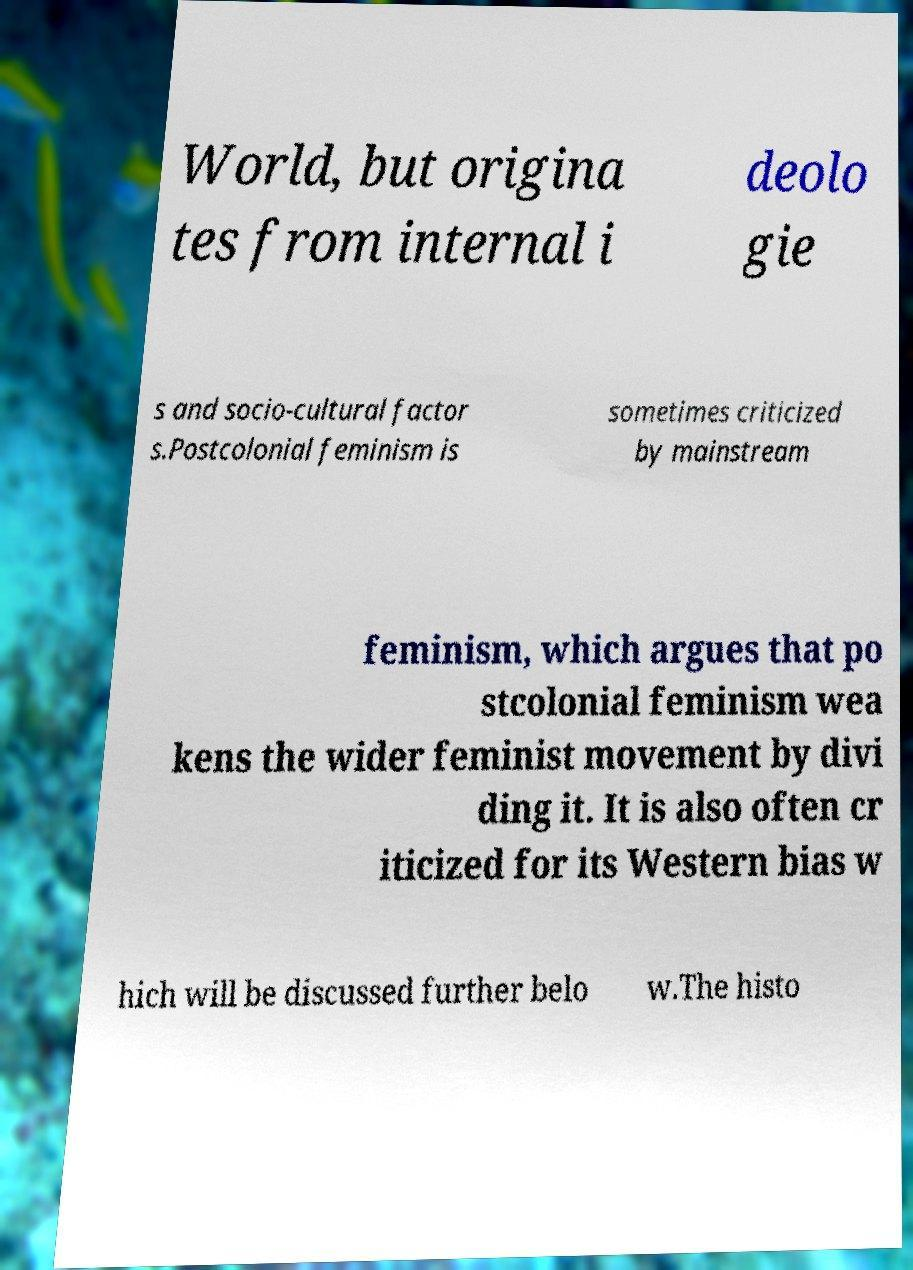There's text embedded in this image that I need extracted. Can you transcribe it verbatim? World, but origina tes from internal i deolo gie s and socio-cultural factor s.Postcolonial feminism is sometimes criticized by mainstream feminism, which argues that po stcolonial feminism wea kens the wider feminist movement by divi ding it. It is also often cr iticized for its Western bias w hich will be discussed further belo w.The histo 